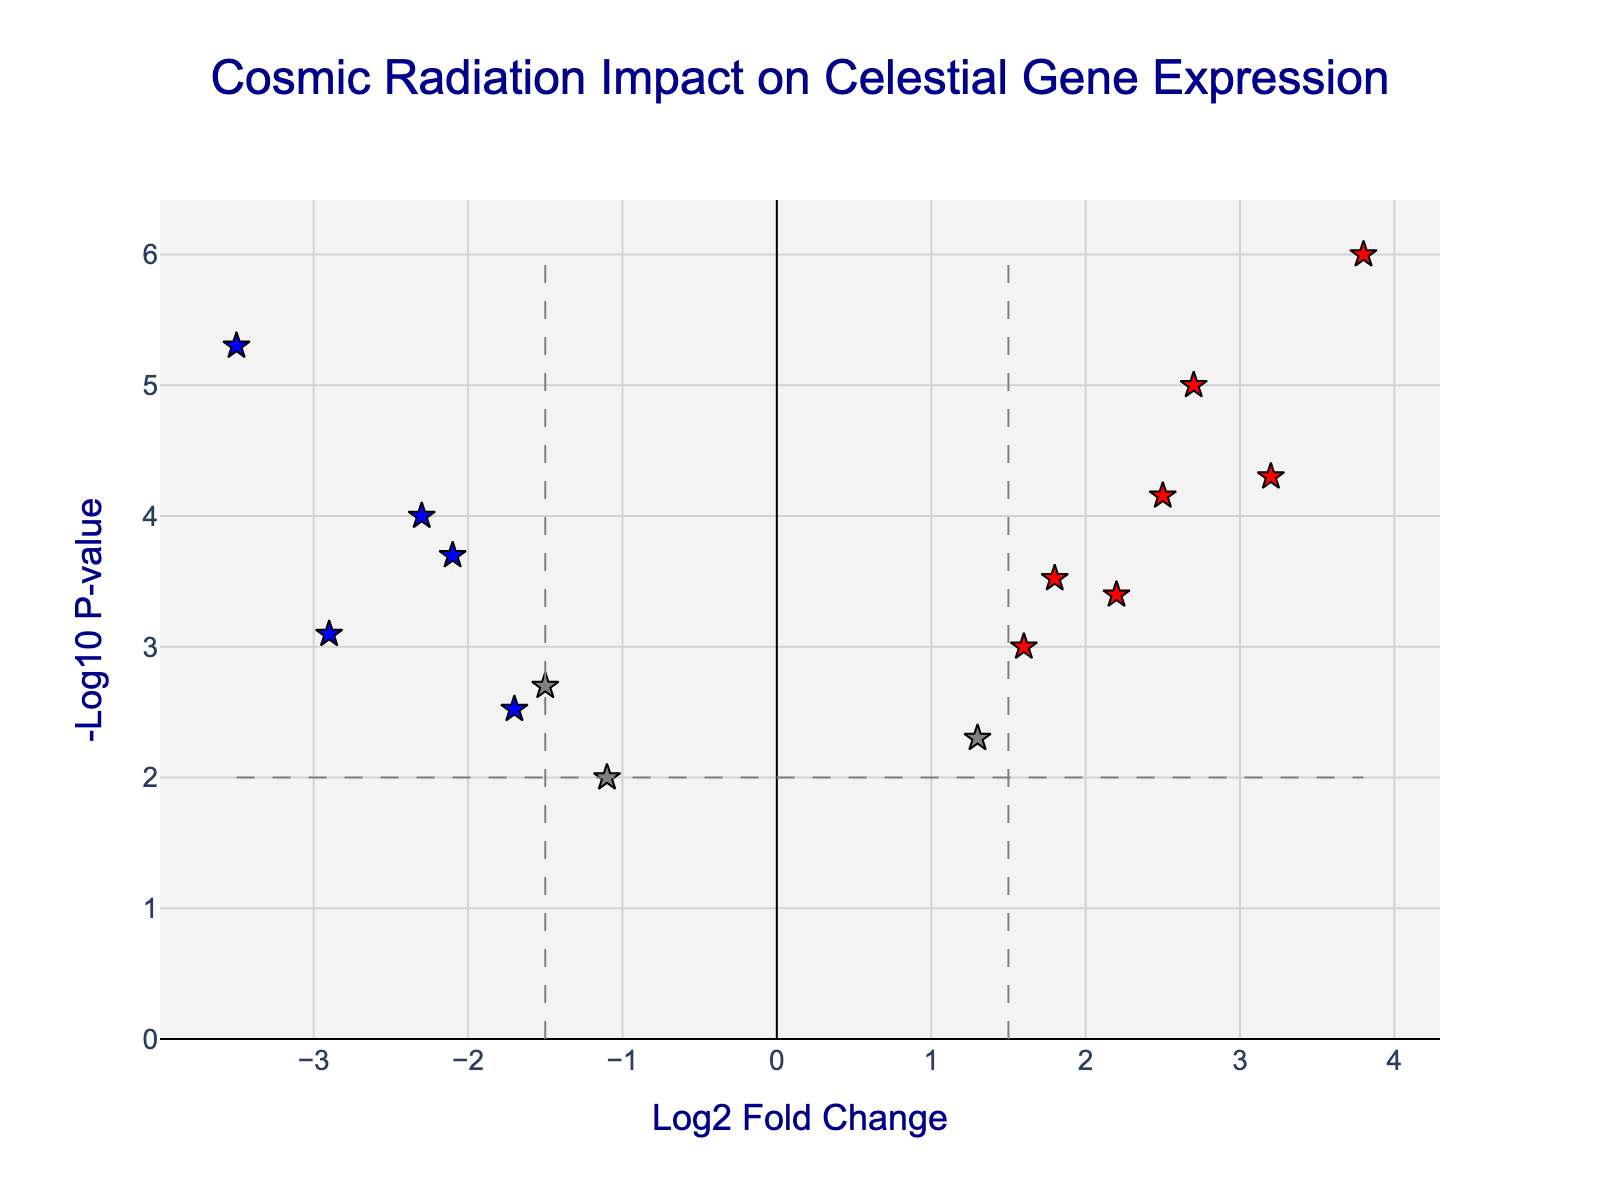how many genes are shown to be upregulated in response to cosmic radiation? To determine the number of upregulated genes, we need to identify the data points colored red on the plot, as these represent genes with a positive log2 fold change greater than 1.5 and a p-value less than 0.01. By counting these red data points, we can answer the question.
Answer: 6 what is the log2 fold change and p-value of the gene with the highest -log10_p value? To find the gene with the highest -log10_p value, locate the data point at the highest y-axis position on the plot. The corresponding x-coordinate provides the log2 fold change, and we can trace back to the data to find the p-value of the gene SUPERNOVA9.
Answer: 3.8 and 0.000001 how many genes are both significantly upregulated and downregulated? Significantly upregulated genes have log2 fold change > 1.5 and p-value < 0.01 (colored red). Significantly downregulated genes have log2 fold change < -1.5 and p-value < 0.01 (colored blue). Count the red and blue points on the plot.
Answer: 8 which gene is downregulated the most, and what is its log2 fold change? Identify the data point with the lowest x-axis value (the most negative log2 fold change). This reflects the gene with the most significant downregulation. The gene is WORMHOLE14, with its detail shown on the plot.
Answer: WORMHOLE14 and -3.5 what is the threshold for the p-value used to consider genes as significant? The threshold for the p-value can be seen as a horizontal dashed line on the plot, which is at -log10(p-value). The value corresponding to this line needs to be traced back to the p-value, which is 0.01.
Answer: 0.01 are there any genes that are not significantly differentially expressed according to the set thresholds? Genes that are not significantly differentially expressed do not meet the log2 fold change threshold (>1.5 or <-1.5) or the p-value threshold (<0.01). Point out the number of grey points that are outside these thresholds.
Answer: yes how does the expression of STELLAR3 compare to NEUTRON10 in the context of cosmic radiation exposure? Examine the position of STELLAR3 and NEUTRON10. STELLAR3 is significantly upregulated (log2 fold change of 3.2, high -log10_p value), whereas NEUTRON10 is significantly downregulated (log2 fold change of -2.1, high -log10_p value). This comparison indicates diverse gene response to cosmic radiation.
Answer: STELLAR3 is upregulated; NEUTRON10 is downregulated 